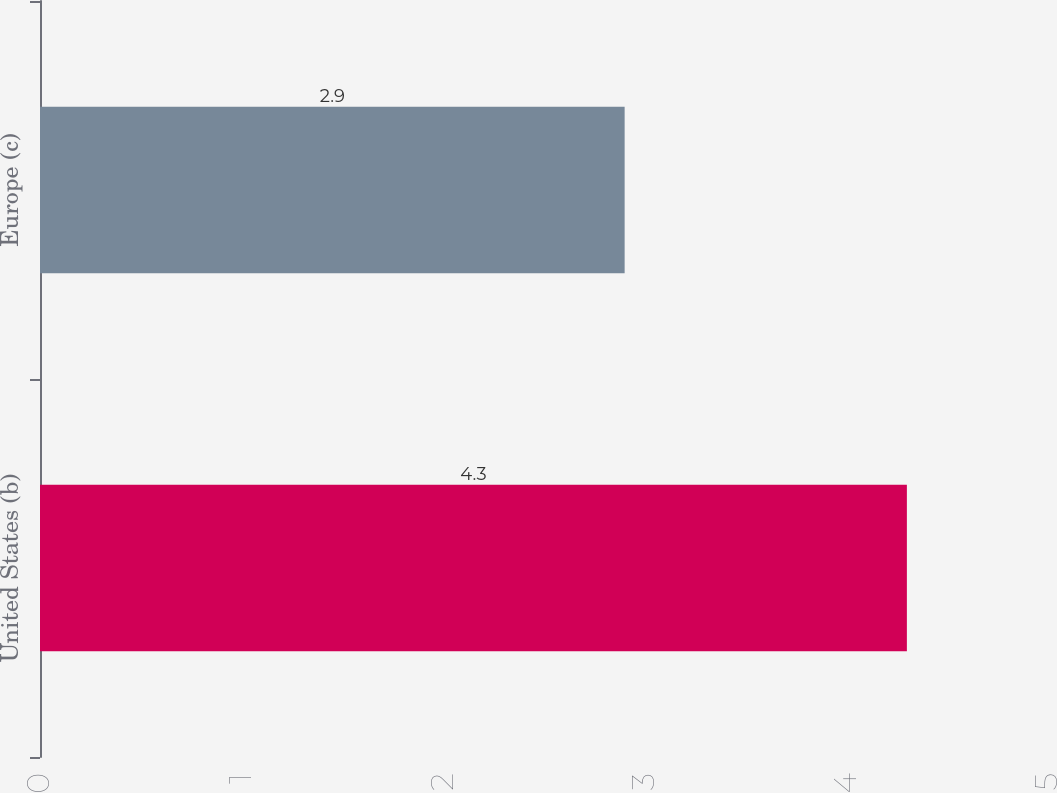Convert chart. <chart><loc_0><loc_0><loc_500><loc_500><bar_chart><fcel>United States (b)<fcel>Europe (c)<nl><fcel>4.3<fcel>2.9<nl></chart> 